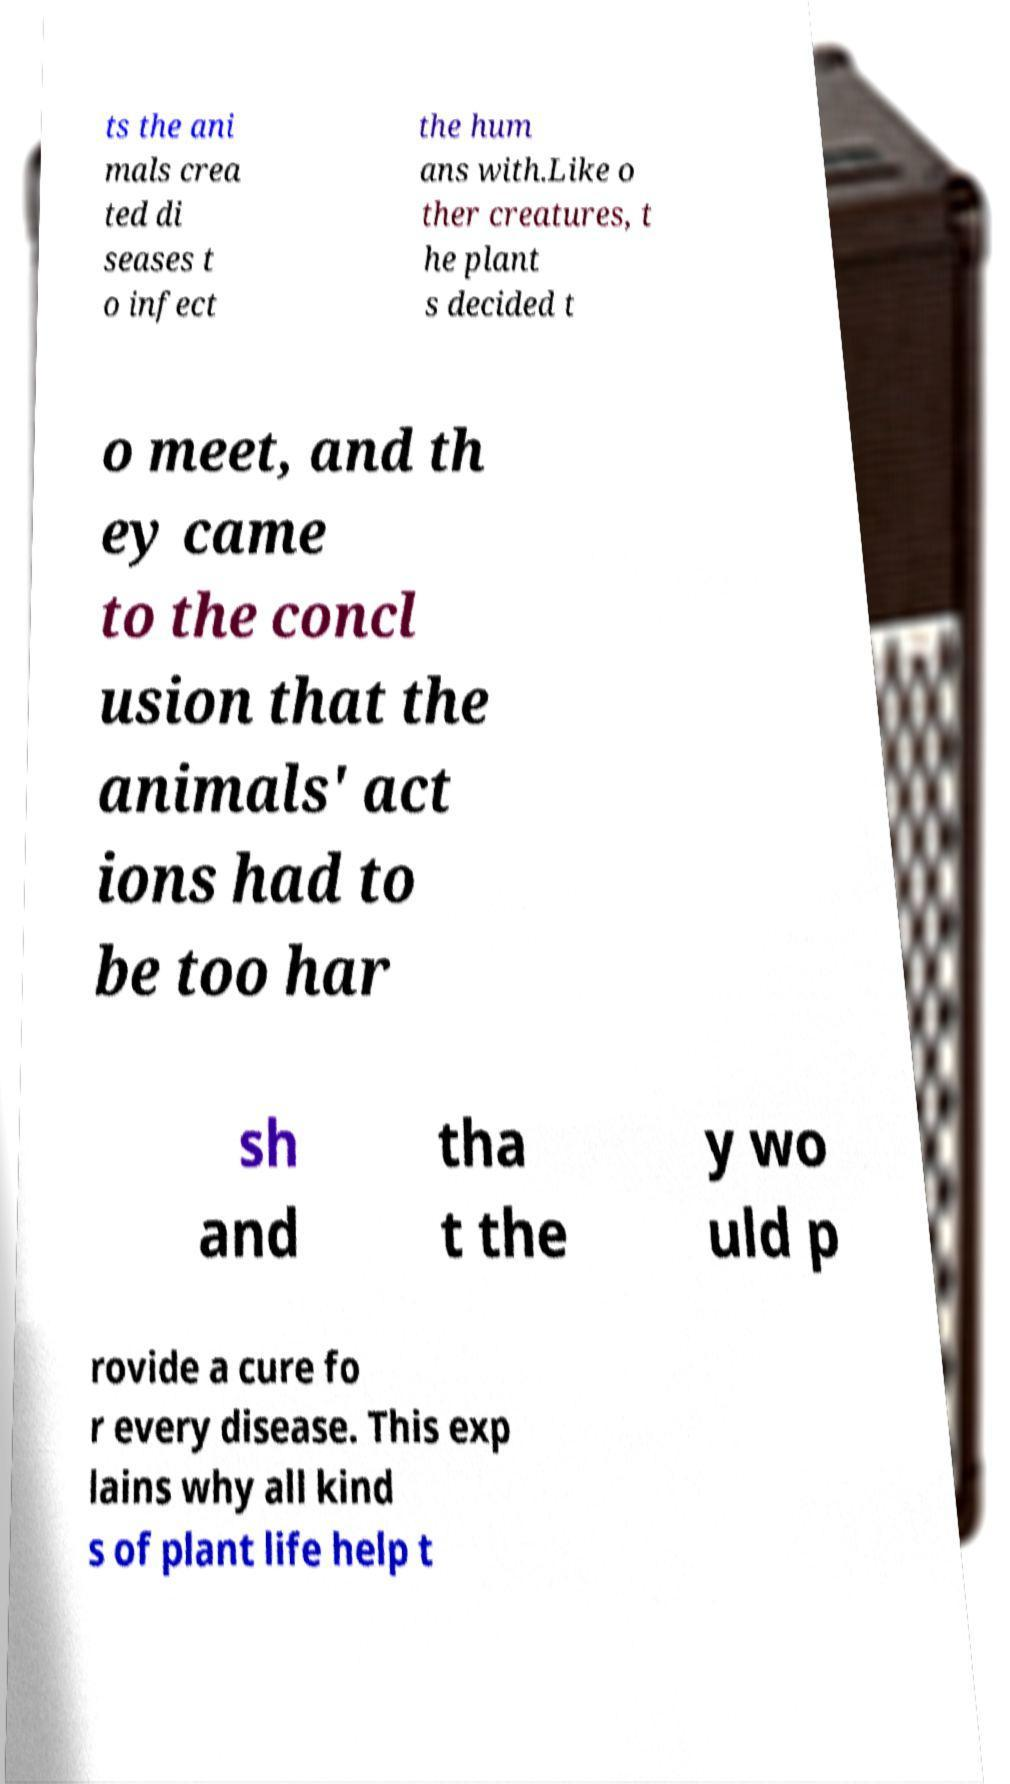Could you extract and type out the text from this image? ts the ani mals crea ted di seases t o infect the hum ans with.Like o ther creatures, t he plant s decided t o meet, and th ey came to the concl usion that the animals' act ions had to be too har sh and tha t the y wo uld p rovide a cure fo r every disease. This exp lains why all kind s of plant life help t 